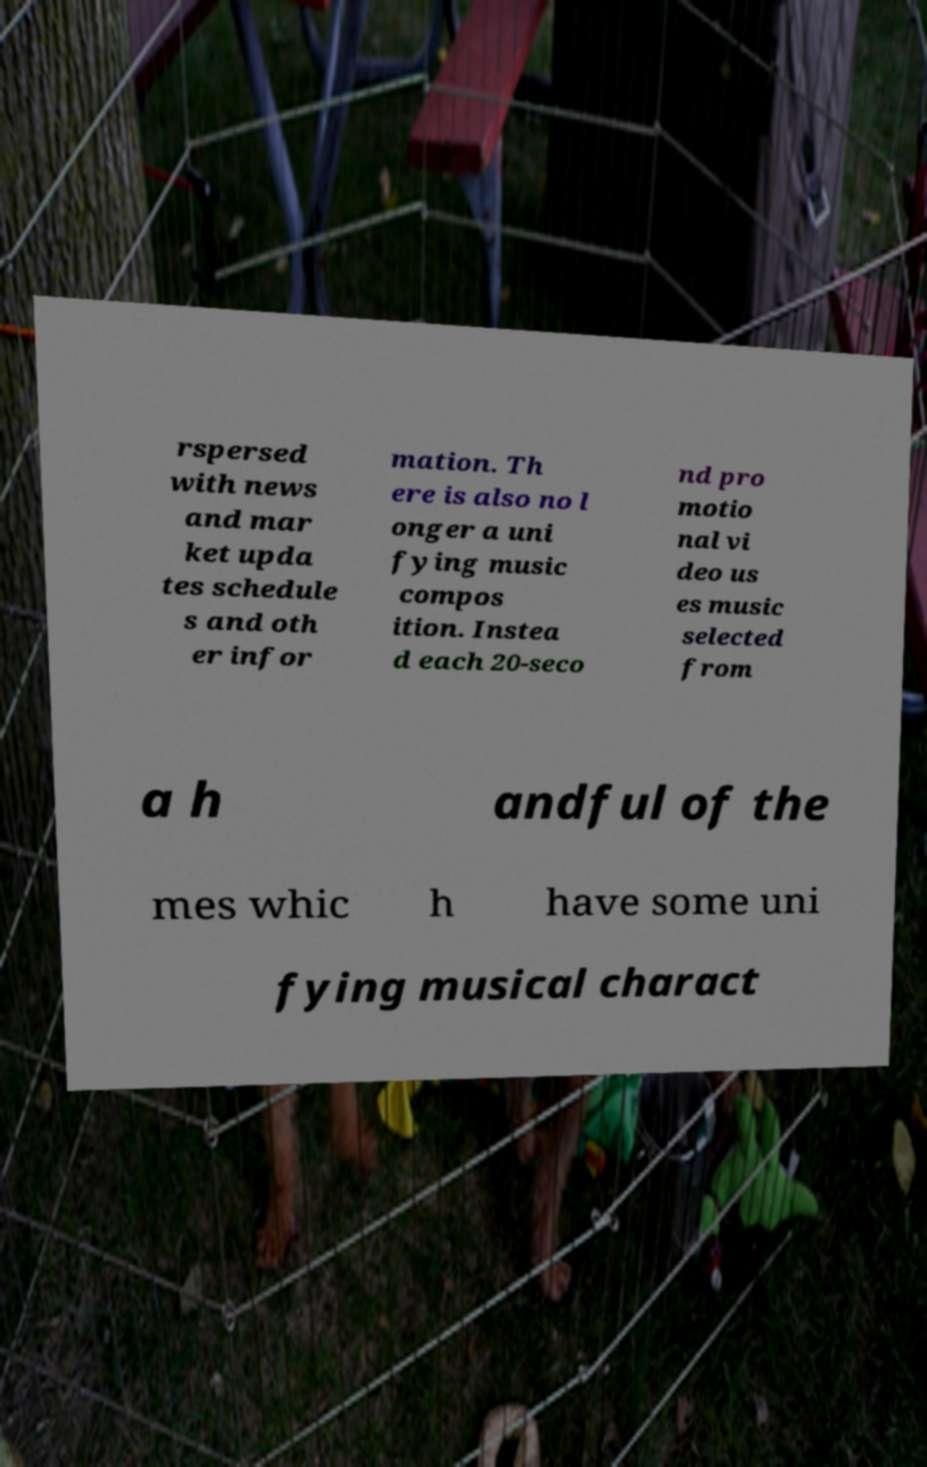Please read and relay the text visible in this image. What does it say? rspersed with news and mar ket upda tes schedule s and oth er infor mation. Th ere is also no l onger a uni fying music compos ition. Instea d each 20-seco nd pro motio nal vi deo us es music selected from a h andful of the mes whic h have some uni fying musical charact 